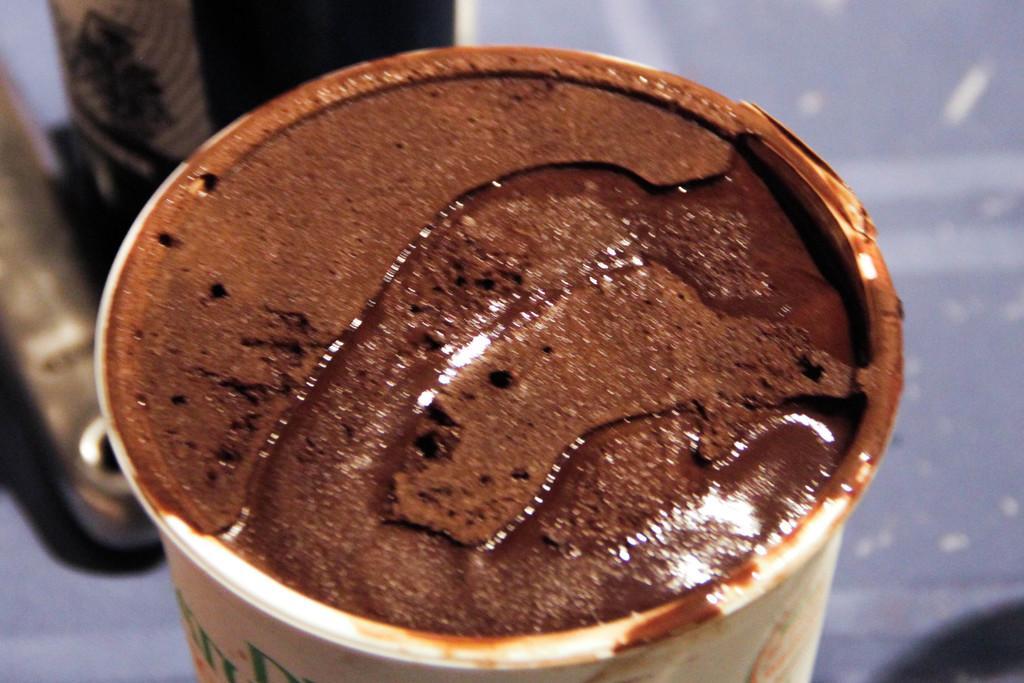Could you give a brief overview of what you see in this image? In this picture we can see a cup. It looks like a liquid and a chocolate paste is visible in this cup. We can see a few objects visible in the background. 